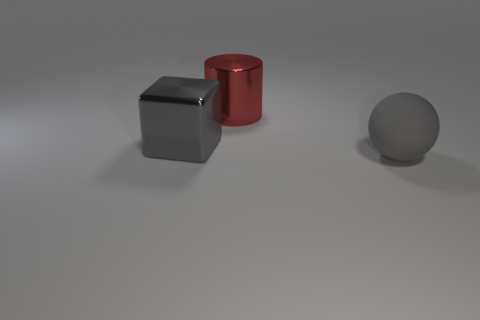Add 2 small yellow balls. How many objects exist? 5 Subtract 0 brown balls. How many objects are left? 3 Subtract all blocks. How many objects are left? 2 Subtract 1 blocks. How many blocks are left? 0 Subtract all brown balls. Subtract all red cylinders. How many balls are left? 1 Subtract all matte spheres. Subtract all shiny blocks. How many objects are left? 1 Add 2 blocks. How many blocks are left? 3 Add 3 big metallic spheres. How many big metallic spheres exist? 3 